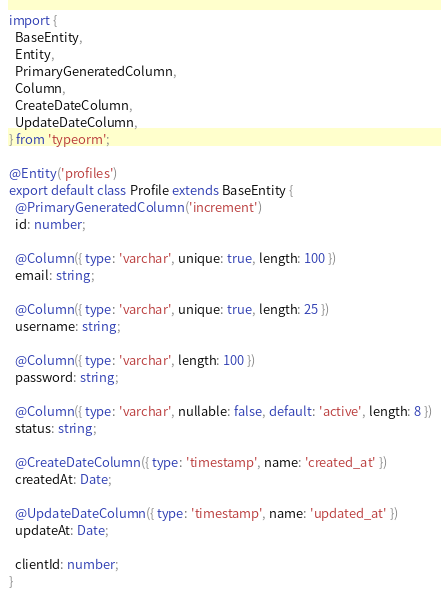Convert code to text. <code><loc_0><loc_0><loc_500><loc_500><_TypeScript_>import {
  BaseEntity,
  Entity,
  PrimaryGeneratedColumn,
  Column,
  CreateDateColumn,
  UpdateDateColumn,
} from 'typeorm';

@Entity('profiles')
export default class Profile extends BaseEntity {
  @PrimaryGeneratedColumn('increment')
  id: number;

  @Column({ type: 'varchar', unique: true, length: 100 })
  email: string;

  @Column({ type: 'varchar', unique: true, length: 25 })
  username: string;

  @Column({ type: 'varchar', length: 100 })
  password: string;

  @Column({ type: 'varchar', nullable: false, default: 'active', length: 8 })
  status: string;

  @CreateDateColumn({ type: 'timestamp', name: 'created_at' })
  createdAt: Date;

  @UpdateDateColumn({ type: 'timestamp', name: 'updated_at' })
  updateAt: Date;

  clientId: number;
}
</code> 